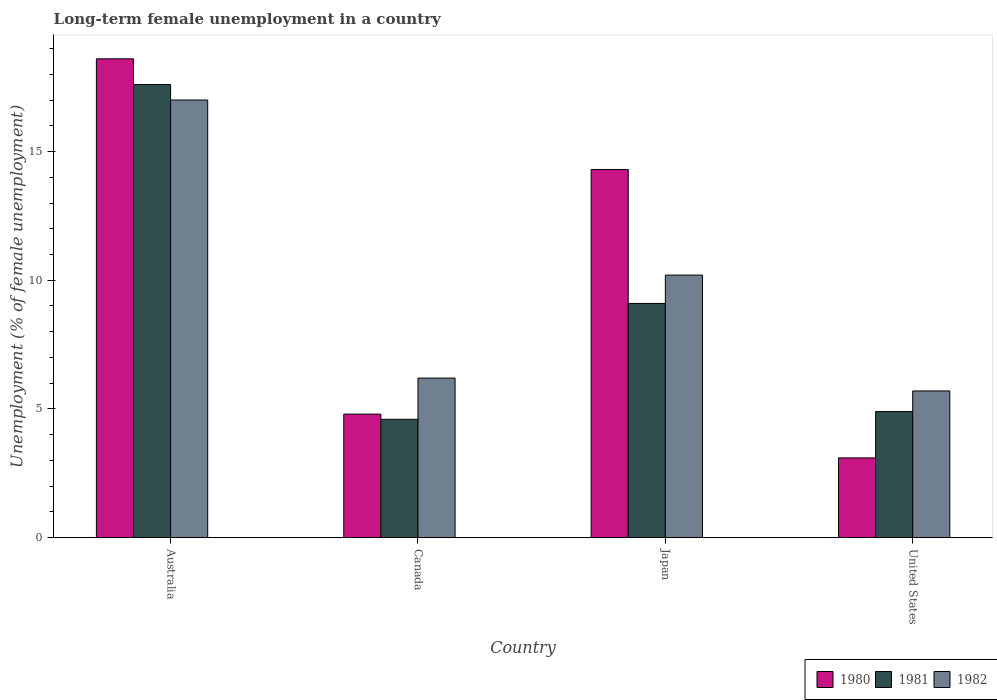How many different coloured bars are there?
Your answer should be compact. 3. How many bars are there on the 4th tick from the left?
Your answer should be compact. 3. How many bars are there on the 3rd tick from the right?
Offer a terse response. 3. What is the percentage of long-term unemployed female population in 1980 in United States?
Offer a terse response. 3.1. Across all countries, what is the maximum percentage of long-term unemployed female population in 1981?
Give a very brief answer. 17.6. Across all countries, what is the minimum percentage of long-term unemployed female population in 1982?
Provide a short and direct response. 5.7. In which country was the percentage of long-term unemployed female population in 1982 minimum?
Your response must be concise. United States. What is the total percentage of long-term unemployed female population in 1981 in the graph?
Offer a very short reply. 36.2. What is the difference between the percentage of long-term unemployed female population in 1981 in Australia and that in United States?
Your response must be concise. 12.7. What is the difference between the percentage of long-term unemployed female population in 1980 in Canada and the percentage of long-term unemployed female population in 1982 in United States?
Your response must be concise. -0.9. What is the average percentage of long-term unemployed female population in 1980 per country?
Offer a very short reply. 10.2. What is the difference between the percentage of long-term unemployed female population of/in 1982 and percentage of long-term unemployed female population of/in 1981 in Japan?
Your response must be concise. 1.1. In how many countries, is the percentage of long-term unemployed female population in 1980 greater than 8 %?
Make the answer very short. 2. What is the ratio of the percentage of long-term unemployed female population in 1982 in Australia to that in United States?
Keep it short and to the point. 2.98. What is the difference between the highest and the second highest percentage of long-term unemployed female population in 1982?
Provide a short and direct response. 6.8. What is the difference between the highest and the lowest percentage of long-term unemployed female population in 1982?
Give a very brief answer. 11.3. In how many countries, is the percentage of long-term unemployed female population in 1981 greater than the average percentage of long-term unemployed female population in 1981 taken over all countries?
Your response must be concise. 2. What does the 2nd bar from the right in Australia represents?
Your answer should be compact. 1981. Is it the case that in every country, the sum of the percentage of long-term unemployed female population in 1980 and percentage of long-term unemployed female population in 1981 is greater than the percentage of long-term unemployed female population in 1982?
Offer a terse response. Yes. What is the difference between two consecutive major ticks on the Y-axis?
Your answer should be very brief. 5. Does the graph contain any zero values?
Your answer should be compact. No. Does the graph contain grids?
Keep it short and to the point. No. Where does the legend appear in the graph?
Your answer should be very brief. Bottom right. How many legend labels are there?
Your answer should be compact. 3. What is the title of the graph?
Your response must be concise. Long-term female unemployment in a country. What is the label or title of the X-axis?
Offer a terse response. Country. What is the label or title of the Y-axis?
Your answer should be very brief. Unemployment (% of female unemployment). What is the Unemployment (% of female unemployment) of 1980 in Australia?
Keep it short and to the point. 18.6. What is the Unemployment (% of female unemployment) in 1981 in Australia?
Your answer should be very brief. 17.6. What is the Unemployment (% of female unemployment) in 1982 in Australia?
Give a very brief answer. 17. What is the Unemployment (% of female unemployment) in 1980 in Canada?
Make the answer very short. 4.8. What is the Unemployment (% of female unemployment) in 1981 in Canada?
Offer a terse response. 4.6. What is the Unemployment (% of female unemployment) of 1982 in Canada?
Ensure brevity in your answer.  6.2. What is the Unemployment (% of female unemployment) in 1980 in Japan?
Make the answer very short. 14.3. What is the Unemployment (% of female unemployment) in 1981 in Japan?
Provide a succinct answer. 9.1. What is the Unemployment (% of female unemployment) in 1982 in Japan?
Make the answer very short. 10.2. What is the Unemployment (% of female unemployment) of 1980 in United States?
Ensure brevity in your answer.  3.1. What is the Unemployment (% of female unemployment) of 1981 in United States?
Offer a very short reply. 4.9. What is the Unemployment (% of female unemployment) in 1982 in United States?
Provide a succinct answer. 5.7. Across all countries, what is the maximum Unemployment (% of female unemployment) in 1980?
Provide a succinct answer. 18.6. Across all countries, what is the maximum Unemployment (% of female unemployment) of 1981?
Give a very brief answer. 17.6. Across all countries, what is the maximum Unemployment (% of female unemployment) in 1982?
Make the answer very short. 17. Across all countries, what is the minimum Unemployment (% of female unemployment) in 1980?
Provide a short and direct response. 3.1. Across all countries, what is the minimum Unemployment (% of female unemployment) of 1981?
Make the answer very short. 4.6. Across all countries, what is the minimum Unemployment (% of female unemployment) of 1982?
Provide a succinct answer. 5.7. What is the total Unemployment (% of female unemployment) in 1980 in the graph?
Offer a very short reply. 40.8. What is the total Unemployment (% of female unemployment) in 1981 in the graph?
Keep it short and to the point. 36.2. What is the total Unemployment (% of female unemployment) in 1982 in the graph?
Make the answer very short. 39.1. What is the difference between the Unemployment (% of female unemployment) in 1980 in Australia and that in Canada?
Provide a short and direct response. 13.8. What is the difference between the Unemployment (% of female unemployment) in 1981 in Australia and that in Canada?
Give a very brief answer. 13. What is the difference between the Unemployment (% of female unemployment) of 1982 in Australia and that in Canada?
Ensure brevity in your answer.  10.8. What is the difference between the Unemployment (% of female unemployment) in 1980 in Australia and that in Japan?
Provide a short and direct response. 4.3. What is the difference between the Unemployment (% of female unemployment) in 1982 in Australia and that in Japan?
Keep it short and to the point. 6.8. What is the difference between the Unemployment (% of female unemployment) in 1981 in Canada and that in Japan?
Offer a terse response. -4.5. What is the difference between the Unemployment (% of female unemployment) in 1982 in Canada and that in Japan?
Keep it short and to the point. -4. What is the difference between the Unemployment (% of female unemployment) in 1980 in Canada and that in United States?
Your answer should be very brief. 1.7. What is the difference between the Unemployment (% of female unemployment) of 1982 in Japan and that in United States?
Offer a terse response. 4.5. What is the difference between the Unemployment (% of female unemployment) of 1981 in Australia and the Unemployment (% of female unemployment) of 1982 in Canada?
Ensure brevity in your answer.  11.4. What is the difference between the Unemployment (% of female unemployment) of 1980 in Australia and the Unemployment (% of female unemployment) of 1981 in Japan?
Ensure brevity in your answer.  9.5. What is the difference between the Unemployment (% of female unemployment) in 1981 in Australia and the Unemployment (% of female unemployment) in 1982 in Japan?
Your answer should be very brief. 7.4. What is the difference between the Unemployment (% of female unemployment) in 1980 in Australia and the Unemployment (% of female unemployment) in 1982 in United States?
Provide a succinct answer. 12.9. What is the difference between the Unemployment (% of female unemployment) in 1980 in Canada and the Unemployment (% of female unemployment) in 1982 in Japan?
Ensure brevity in your answer.  -5.4. What is the difference between the Unemployment (% of female unemployment) in 1980 in Canada and the Unemployment (% of female unemployment) in 1981 in United States?
Give a very brief answer. -0.1. What is the difference between the Unemployment (% of female unemployment) in 1980 in Canada and the Unemployment (% of female unemployment) in 1982 in United States?
Offer a very short reply. -0.9. What is the difference between the Unemployment (% of female unemployment) in 1981 in Canada and the Unemployment (% of female unemployment) in 1982 in United States?
Offer a terse response. -1.1. What is the difference between the Unemployment (% of female unemployment) in 1980 in Japan and the Unemployment (% of female unemployment) in 1982 in United States?
Keep it short and to the point. 8.6. What is the difference between the Unemployment (% of female unemployment) of 1981 in Japan and the Unemployment (% of female unemployment) of 1982 in United States?
Keep it short and to the point. 3.4. What is the average Unemployment (% of female unemployment) in 1981 per country?
Offer a terse response. 9.05. What is the average Unemployment (% of female unemployment) of 1982 per country?
Keep it short and to the point. 9.78. What is the difference between the Unemployment (% of female unemployment) in 1980 and Unemployment (% of female unemployment) in 1981 in Australia?
Your answer should be compact. 1. What is the difference between the Unemployment (% of female unemployment) in 1981 and Unemployment (% of female unemployment) in 1982 in Australia?
Provide a succinct answer. 0.6. What is the difference between the Unemployment (% of female unemployment) in 1981 and Unemployment (% of female unemployment) in 1982 in Canada?
Your response must be concise. -1.6. What is the difference between the Unemployment (% of female unemployment) in 1980 and Unemployment (% of female unemployment) in 1981 in Japan?
Provide a short and direct response. 5.2. What is the difference between the Unemployment (% of female unemployment) in 1980 and Unemployment (% of female unemployment) in 1982 in Japan?
Your answer should be compact. 4.1. What is the difference between the Unemployment (% of female unemployment) of 1981 and Unemployment (% of female unemployment) of 1982 in Japan?
Your answer should be compact. -1.1. What is the difference between the Unemployment (% of female unemployment) in 1980 and Unemployment (% of female unemployment) in 1981 in United States?
Offer a very short reply. -1.8. What is the difference between the Unemployment (% of female unemployment) of 1980 and Unemployment (% of female unemployment) of 1982 in United States?
Give a very brief answer. -2.6. What is the difference between the Unemployment (% of female unemployment) in 1981 and Unemployment (% of female unemployment) in 1982 in United States?
Your answer should be very brief. -0.8. What is the ratio of the Unemployment (% of female unemployment) in 1980 in Australia to that in Canada?
Your answer should be very brief. 3.88. What is the ratio of the Unemployment (% of female unemployment) of 1981 in Australia to that in Canada?
Keep it short and to the point. 3.83. What is the ratio of the Unemployment (% of female unemployment) in 1982 in Australia to that in Canada?
Make the answer very short. 2.74. What is the ratio of the Unemployment (% of female unemployment) in 1980 in Australia to that in Japan?
Your answer should be compact. 1.3. What is the ratio of the Unemployment (% of female unemployment) of 1981 in Australia to that in Japan?
Give a very brief answer. 1.93. What is the ratio of the Unemployment (% of female unemployment) in 1980 in Australia to that in United States?
Your response must be concise. 6. What is the ratio of the Unemployment (% of female unemployment) in 1981 in Australia to that in United States?
Ensure brevity in your answer.  3.59. What is the ratio of the Unemployment (% of female unemployment) in 1982 in Australia to that in United States?
Your answer should be compact. 2.98. What is the ratio of the Unemployment (% of female unemployment) of 1980 in Canada to that in Japan?
Provide a succinct answer. 0.34. What is the ratio of the Unemployment (% of female unemployment) in 1981 in Canada to that in Japan?
Provide a short and direct response. 0.51. What is the ratio of the Unemployment (% of female unemployment) of 1982 in Canada to that in Japan?
Your answer should be compact. 0.61. What is the ratio of the Unemployment (% of female unemployment) in 1980 in Canada to that in United States?
Ensure brevity in your answer.  1.55. What is the ratio of the Unemployment (% of female unemployment) in 1981 in Canada to that in United States?
Ensure brevity in your answer.  0.94. What is the ratio of the Unemployment (% of female unemployment) of 1982 in Canada to that in United States?
Keep it short and to the point. 1.09. What is the ratio of the Unemployment (% of female unemployment) in 1980 in Japan to that in United States?
Your response must be concise. 4.61. What is the ratio of the Unemployment (% of female unemployment) in 1981 in Japan to that in United States?
Provide a succinct answer. 1.86. What is the ratio of the Unemployment (% of female unemployment) in 1982 in Japan to that in United States?
Your answer should be very brief. 1.79. What is the difference between the highest and the second highest Unemployment (% of female unemployment) of 1980?
Give a very brief answer. 4.3. What is the difference between the highest and the second highest Unemployment (% of female unemployment) in 1981?
Offer a terse response. 8.5. What is the difference between the highest and the lowest Unemployment (% of female unemployment) in 1982?
Your response must be concise. 11.3. 